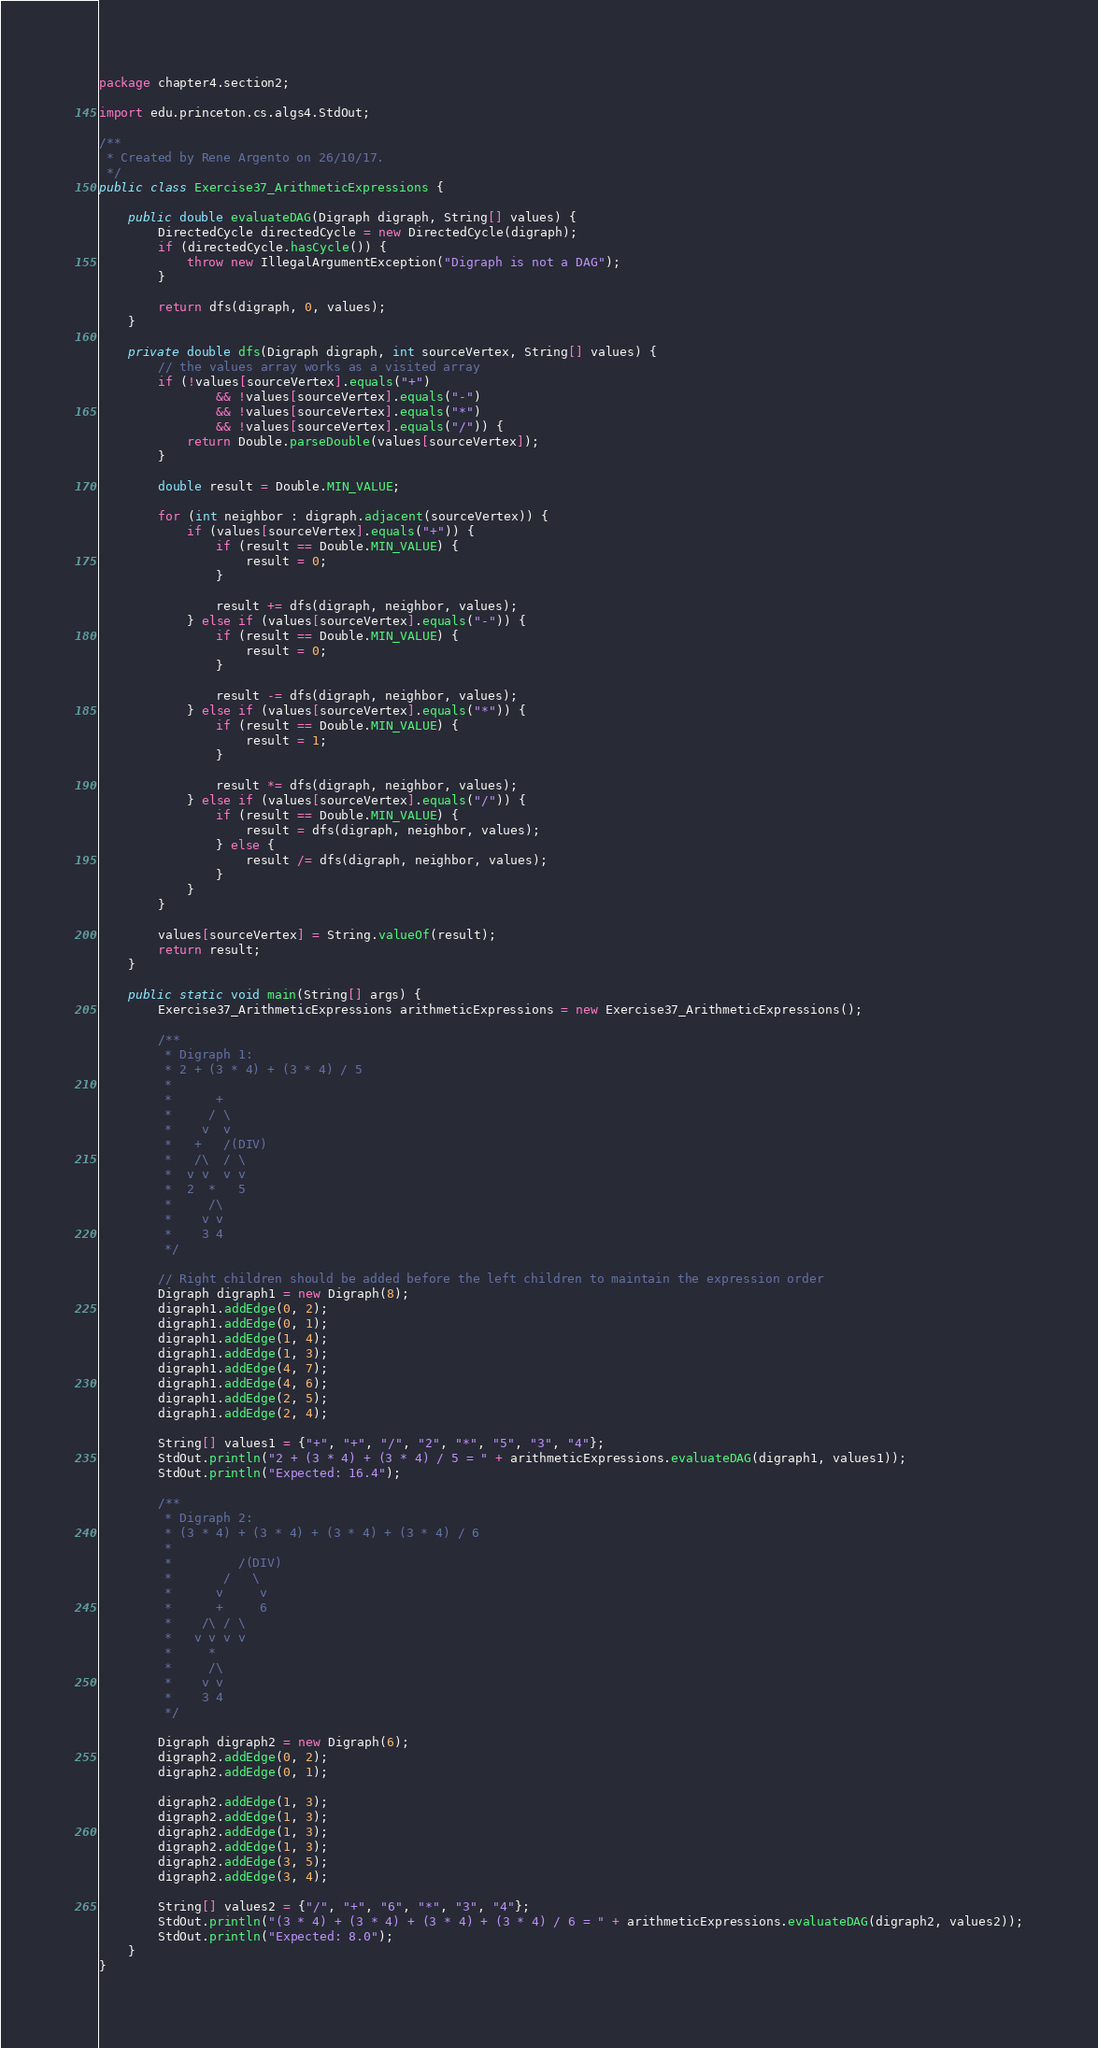Convert code to text. <code><loc_0><loc_0><loc_500><loc_500><_Java_>package chapter4.section2;

import edu.princeton.cs.algs4.StdOut;

/**
 * Created by Rene Argento on 26/10/17.
 */
public class Exercise37_ArithmeticExpressions {

    public double evaluateDAG(Digraph digraph, String[] values) {
        DirectedCycle directedCycle = new DirectedCycle(digraph);
        if (directedCycle.hasCycle()) {
            throw new IllegalArgumentException("Digraph is not a DAG");
        }

        return dfs(digraph, 0, values);
    }

    private double dfs(Digraph digraph, int sourceVertex, String[] values) {
        // the values array works as a visited array
        if (!values[sourceVertex].equals("+")
                && !values[sourceVertex].equals("-")
                && !values[sourceVertex].equals("*")
                && !values[sourceVertex].equals("/")) {
            return Double.parseDouble(values[sourceVertex]);
        }

        double result = Double.MIN_VALUE;

        for (int neighbor : digraph.adjacent(sourceVertex)) {
            if (values[sourceVertex].equals("+")) {
                if (result == Double.MIN_VALUE) {
                    result = 0;
                }

                result += dfs(digraph, neighbor, values);
            } else if (values[sourceVertex].equals("-")) {
                if (result == Double.MIN_VALUE) {
                    result = 0;
                }

                result -= dfs(digraph, neighbor, values);
            } else if (values[sourceVertex].equals("*")) {
                if (result == Double.MIN_VALUE) {
                    result = 1;
                }

                result *= dfs(digraph, neighbor, values);
            } else if (values[sourceVertex].equals("/")) {
                if (result == Double.MIN_VALUE) {
                    result = dfs(digraph, neighbor, values);
                } else {
                    result /= dfs(digraph, neighbor, values);
                }
            }
        }

        values[sourceVertex] = String.valueOf(result);
        return result;
    }

    public static void main(String[] args) {
        Exercise37_ArithmeticExpressions arithmeticExpressions = new Exercise37_ArithmeticExpressions();

        /**
         * Digraph 1:
         * 2 + (3 * 4) + (3 * 4) / 5
         *
         *      +
         *     / \
         *    v  v
         *   +   /(DIV)
         *   /\  / \
         *  v v  v v
         *  2  *   5
         *     /\
         *    v v
         *    3 4
         */

        // Right children should be added before the left children to maintain the expression order
        Digraph digraph1 = new Digraph(8);
        digraph1.addEdge(0, 2);
        digraph1.addEdge(0, 1);
        digraph1.addEdge(1, 4);
        digraph1.addEdge(1, 3);
        digraph1.addEdge(4, 7);
        digraph1.addEdge(4, 6);
        digraph1.addEdge(2, 5);
        digraph1.addEdge(2, 4);

        String[] values1 = {"+", "+", "/", "2", "*", "5", "3", "4"};
        StdOut.println("2 + (3 * 4) + (3 * 4) / 5 = " + arithmeticExpressions.evaluateDAG(digraph1, values1));
        StdOut.println("Expected: 16.4");

        /**
         * Digraph 2:
         * (3 * 4) + (3 * 4) + (3 * 4) + (3 * 4) / 6
         *
         *         /(DIV)
         *       /   \
         *      v     v
         *      +     6
         *    /\ / \
         *   v v v v
         *     *
         *     /\
         *    v v
         *    3 4
         */

        Digraph digraph2 = new Digraph(6);
        digraph2.addEdge(0, 2);
        digraph2.addEdge(0, 1);

        digraph2.addEdge(1, 3);
        digraph2.addEdge(1, 3);
        digraph2.addEdge(1, 3);
        digraph2.addEdge(1, 3);
        digraph2.addEdge(3, 5);
        digraph2.addEdge(3, 4);

        String[] values2 = {"/", "+", "6", "*", "3", "4"};
        StdOut.println("(3 * 4) + (3 * 4) + (3 * 4) + (3 * 4) / 6 = " + arithmeticExpressions.evaluateDAG(digraph2, values2));
        StdOut.println("Expected: 8.0");
    }
}
</code> 